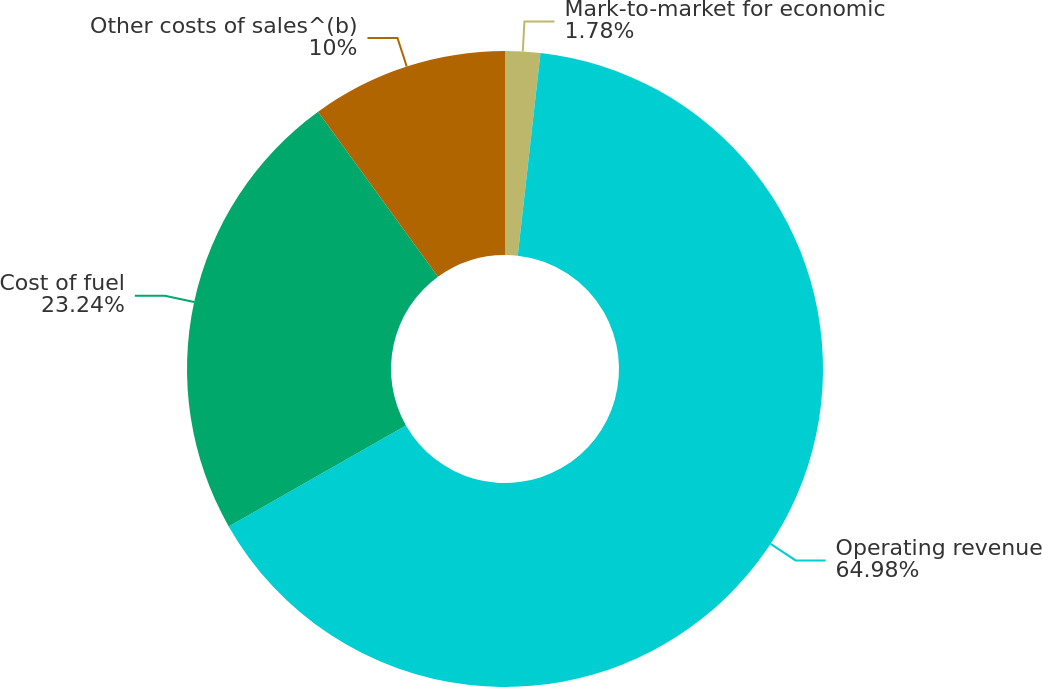Convert chart to OTSL. <chart><loc_0><loc_0><loc_500><loc_500><pie_chart><fcel>Mark-to-market for economic<fcel>Operating revenue<fcel>Cost of fuel<fcel>Other costs of sales^(b)<nl><fcel>1.78%<fcel>64.98%<fcel>23.24%<fcel>10.0%<nl></chart> 